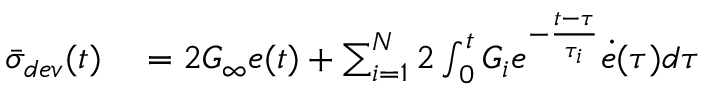Convert formula to latex. <formula><loc_0><loc_0><loc_500><loc_500>\begin{array} { r l } { { \bar { \sigma } _ { d e v } } ( t ) } & = 2 G _ { \infty } e ( t ) + \sum _ { i = 1 } ^ { N } 2 \int _ { 0 } ^ { t } G _ { i } e ^ { - \frac { t - \tau } { \tau _ { i } } } \dot { e } ( \tau ) d \tau } \end{array}</formula> 